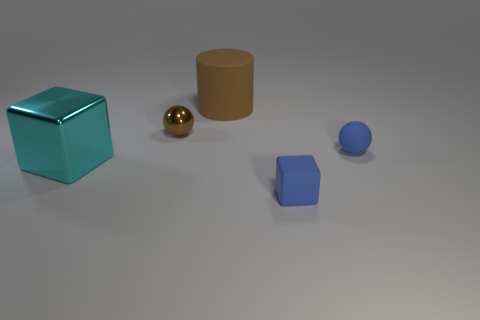What number of other things are the same material as the tiny blue sphere?
Offer a terse response. 2. Is the number of cyan metallic cubes greater than the number of cubes?
Ensure brevity in your answer.  No. There is a tiny blue object behind the big cyan cube; is its shape the same as the tiny brown metal object?
Offer a very short reply. Yes. Is the number of tiny yellow things less than the number of large brown cylinders?
Offer a terse response. Yes. There is a cyan cube that is the same size as the cylinder; what is it made of?
Make the answer very short. Metal. There is a large matte thing; is it the same color as the rubber thing that is on the right side of the tiny blue block?
Ensure brevity in your answer.  No. Are there fewer tiny matte cubes that are behind the cyan metal cube than rubber cubes?
Provide a short and direct response. Yes. What number of big cyan objects are there?
Your answer should be very brief. 1. The large object that is in front of the tiny blue object that is behind the shiny cube is what shape?
Your answer should be very brief. Cube. There is a cyan shiny cube; how many big cubes are to the right of it?
Offer a very short reply. 0. 